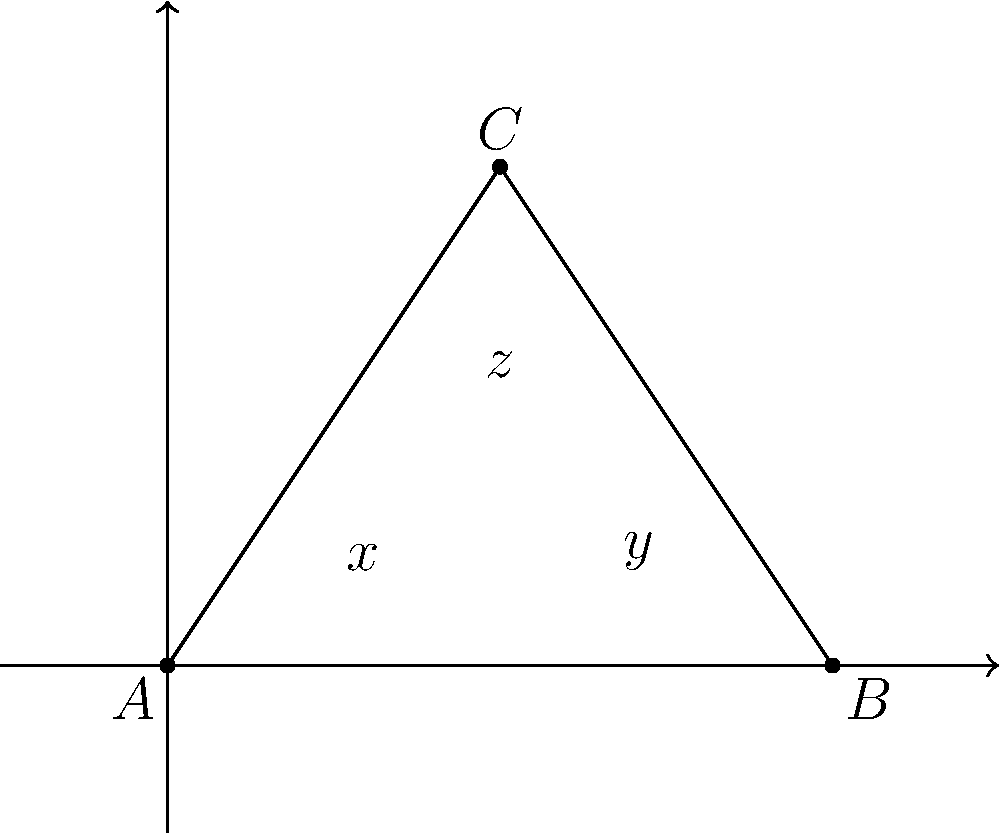Three UFOs are detected flying in a triangular formation. The angles formed by their intersecting flight paths are labeled $x°$, $y°$, and $z°$ as shown in the diagram. If $x = 65°$ and $y = 50°$, what is the value of $z$? To solve this problem, we'll use the property that the sum of angles in a triangle is always 180°. Let's approach this step-by-step:

1) In any triangle, the sum of all interior angles is 180°. Therefore:

   $x° + y° + z° = 180°$

2) We are given that $x = 65°$ and $y = 50°$. Let's substitute these values:

   $65° + 50° + z° = 180°$

3) Simplify the left side of the equation:

   $115° + z° = 180°$

4) To isolate $z$, subtract 115° from both sides:

   $z° = 180° - 115°$

5) Perform the subtraction:

   $z° = 65°$

Therefore, the value of $z$ is 65°.
Answer: $65°$ 